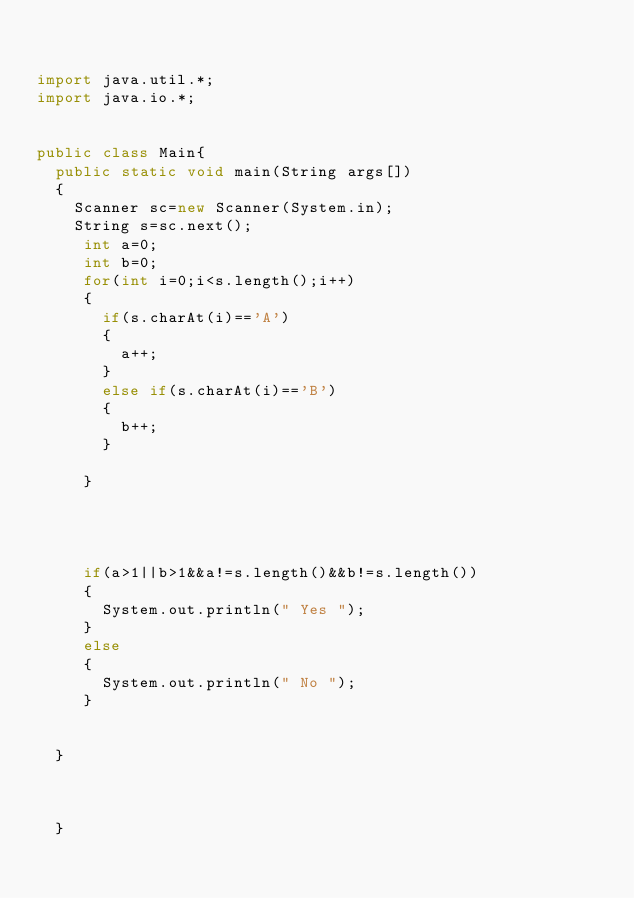<code> <loc_0><loc_0><loc_500><loc_500><_Java_>

import java.util.*;
import java.io.*;


public class Main{
	public static void main(String args[])
	{
		Scanner sc=new Scanner(System.in);
		String s=sc.next();
		 int a=0;
		 int b=0;
		 for(int i=0;i<s.length();i++)
		 {
			 if(s.charAt(i)=='A')
			 {
				 a++;
			 }
			 else if(s.charAt(i)=='B')
			 {
				 b++;
			 }
			 
		 }
		 
		 
		 
		 
		 if(a>1||b>1&&a!=s.length()&&b!=s.length())
		 {
			 System.out.println(" Yes ");
		 }
		 else
		 {
			 System.out.println(" No ");
		 }
		
		
	}



	}







</code> 